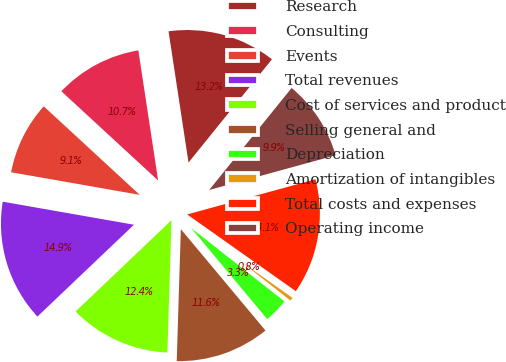Convert chart. <chart><loc_0><loc_0><loc_500><loc_500><pie_chart><fcel>Research<fcel>Consulting<fcel>Events<fcel>Total revenues<fcel>Cost of services and product<fcel>Selling general and<fcel>Depreciation<fcel>Amortization of intangibles<fcel>Total costs and expenses<fcel>Operating income<nl><fcel>13.22%<fcel>10.74%<fcel>9.09%<fcel>14.87%<fcel>12.4%<fcel>11.57%<fcel>3.31%<fcel>0.83%<fcel>14.05%<fcel>9.92%<nl></chart> 